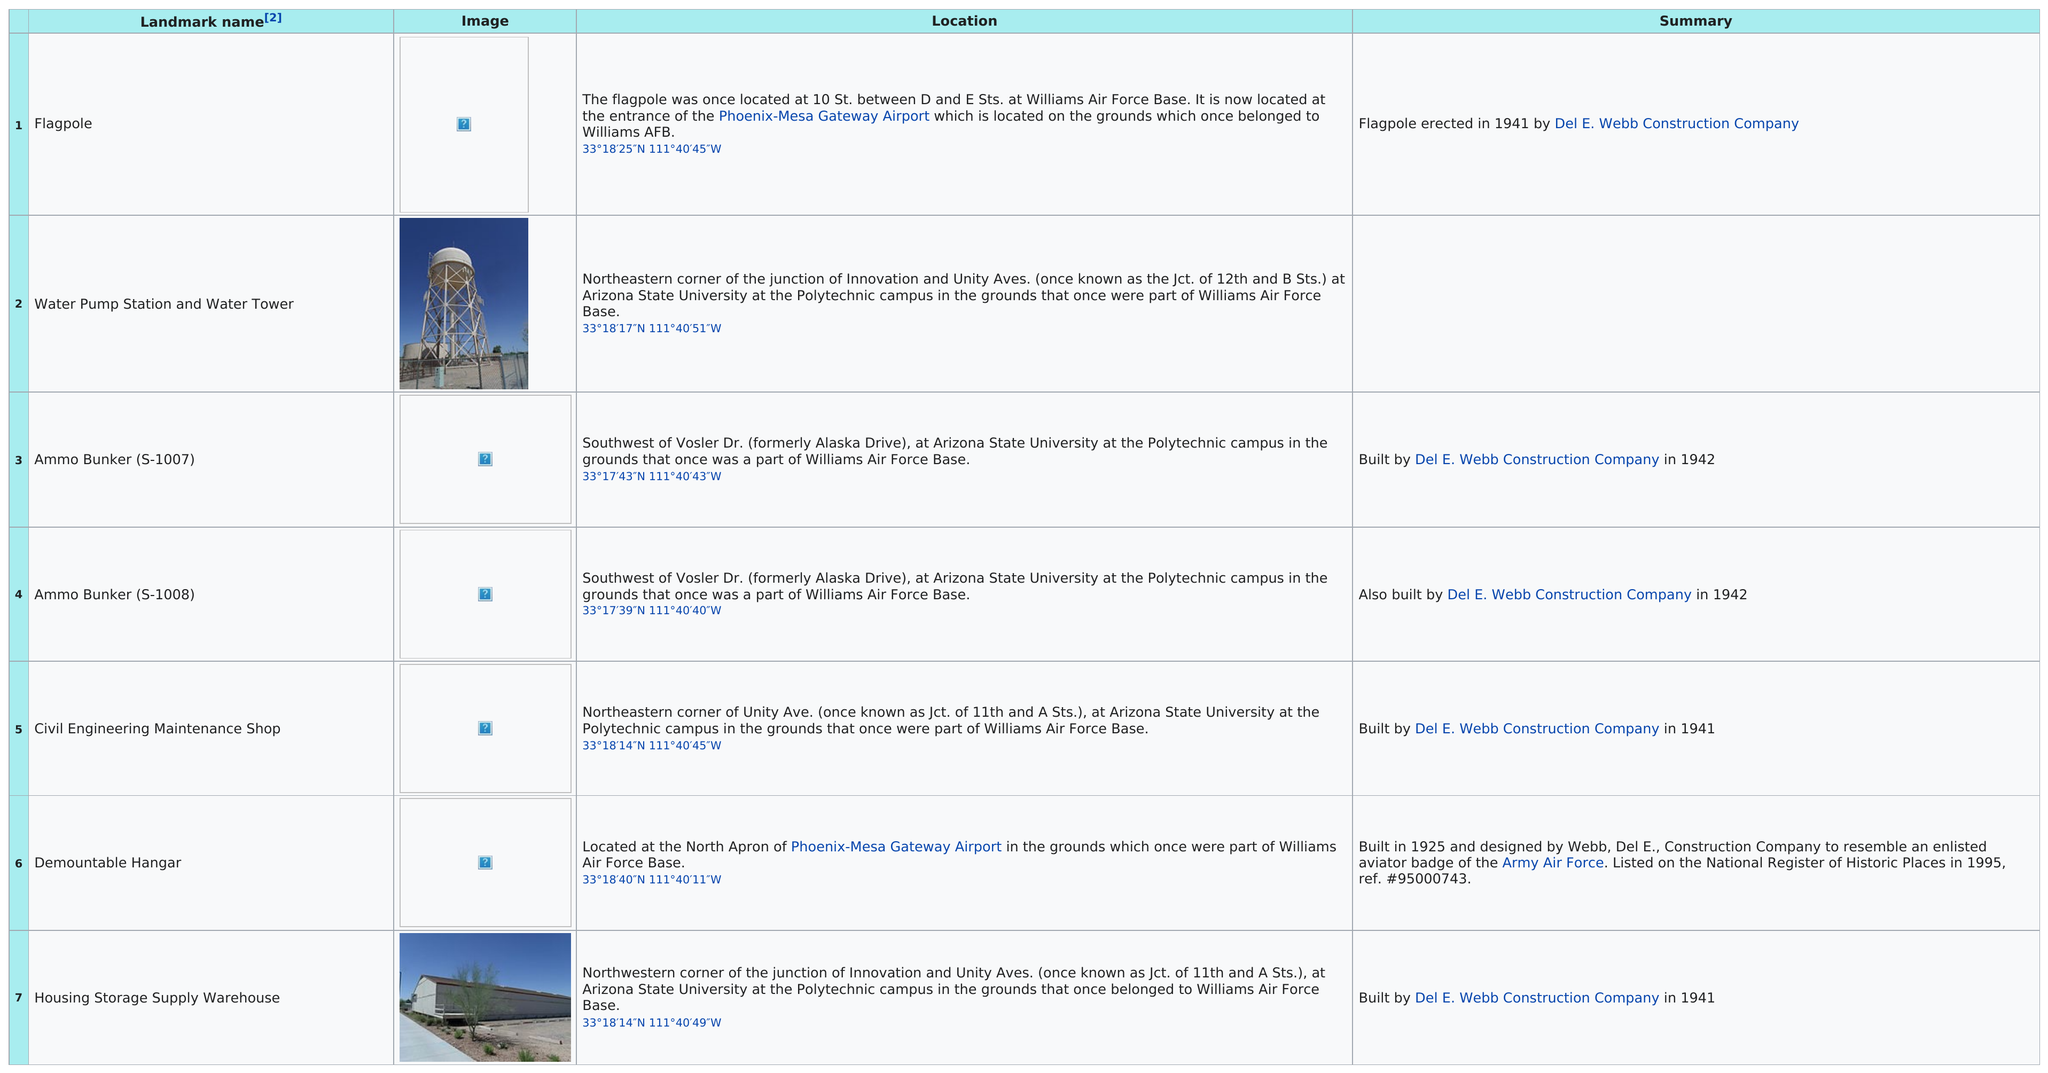Draw attention to some important aspects in this diagram. The Demountable Hangar is the landmark that was built the longest ago. Demountable Hangar, a landmark built by Del E. Webb Construction Company and designed to resemble an enlisted aviator badge, was also constructed in Del Rio, Texas. Of the landmarks, two are defined as bunkers. The flagpole that was previously located at 10th Street between D and E Streets at Williams Air Force Base and is now located at the entrance of Phoenix-Mesa Gateway Airport is the Flagpole. Five landmarks were under the jurisdiction of Del E. Webb Construction Company. 